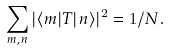<formula> <loc_0><loc_0><loc_500><loc_500>\sum _ { m , n } | \langle m | T | n \rangle | ^ { 2 } = 1 / N .</formula> 